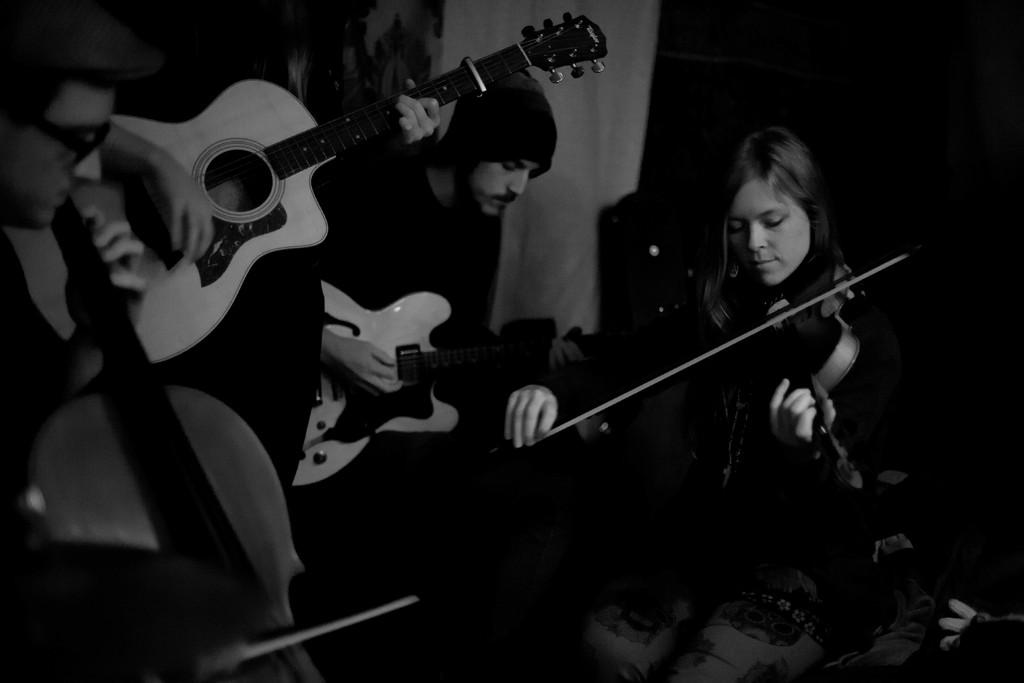What is the color scheme of the image? The image is black and white. Can you describe the activities of the persons in the image? One person is playing a guitar, and another person is playing a violin. What type of frame is surrounding the yam in the image? There is no yam or frame present in the image. Is the dirt visible in the image? There is no dirt visible in the image. 